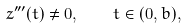Convert formula to latex. <formula><loc_0><loc_0><loc_500><loc_500>z ^ { \prime \prime \prime } ( t ) \neq 0 , \quad t \in ( 0 , b ) ,</formula> 